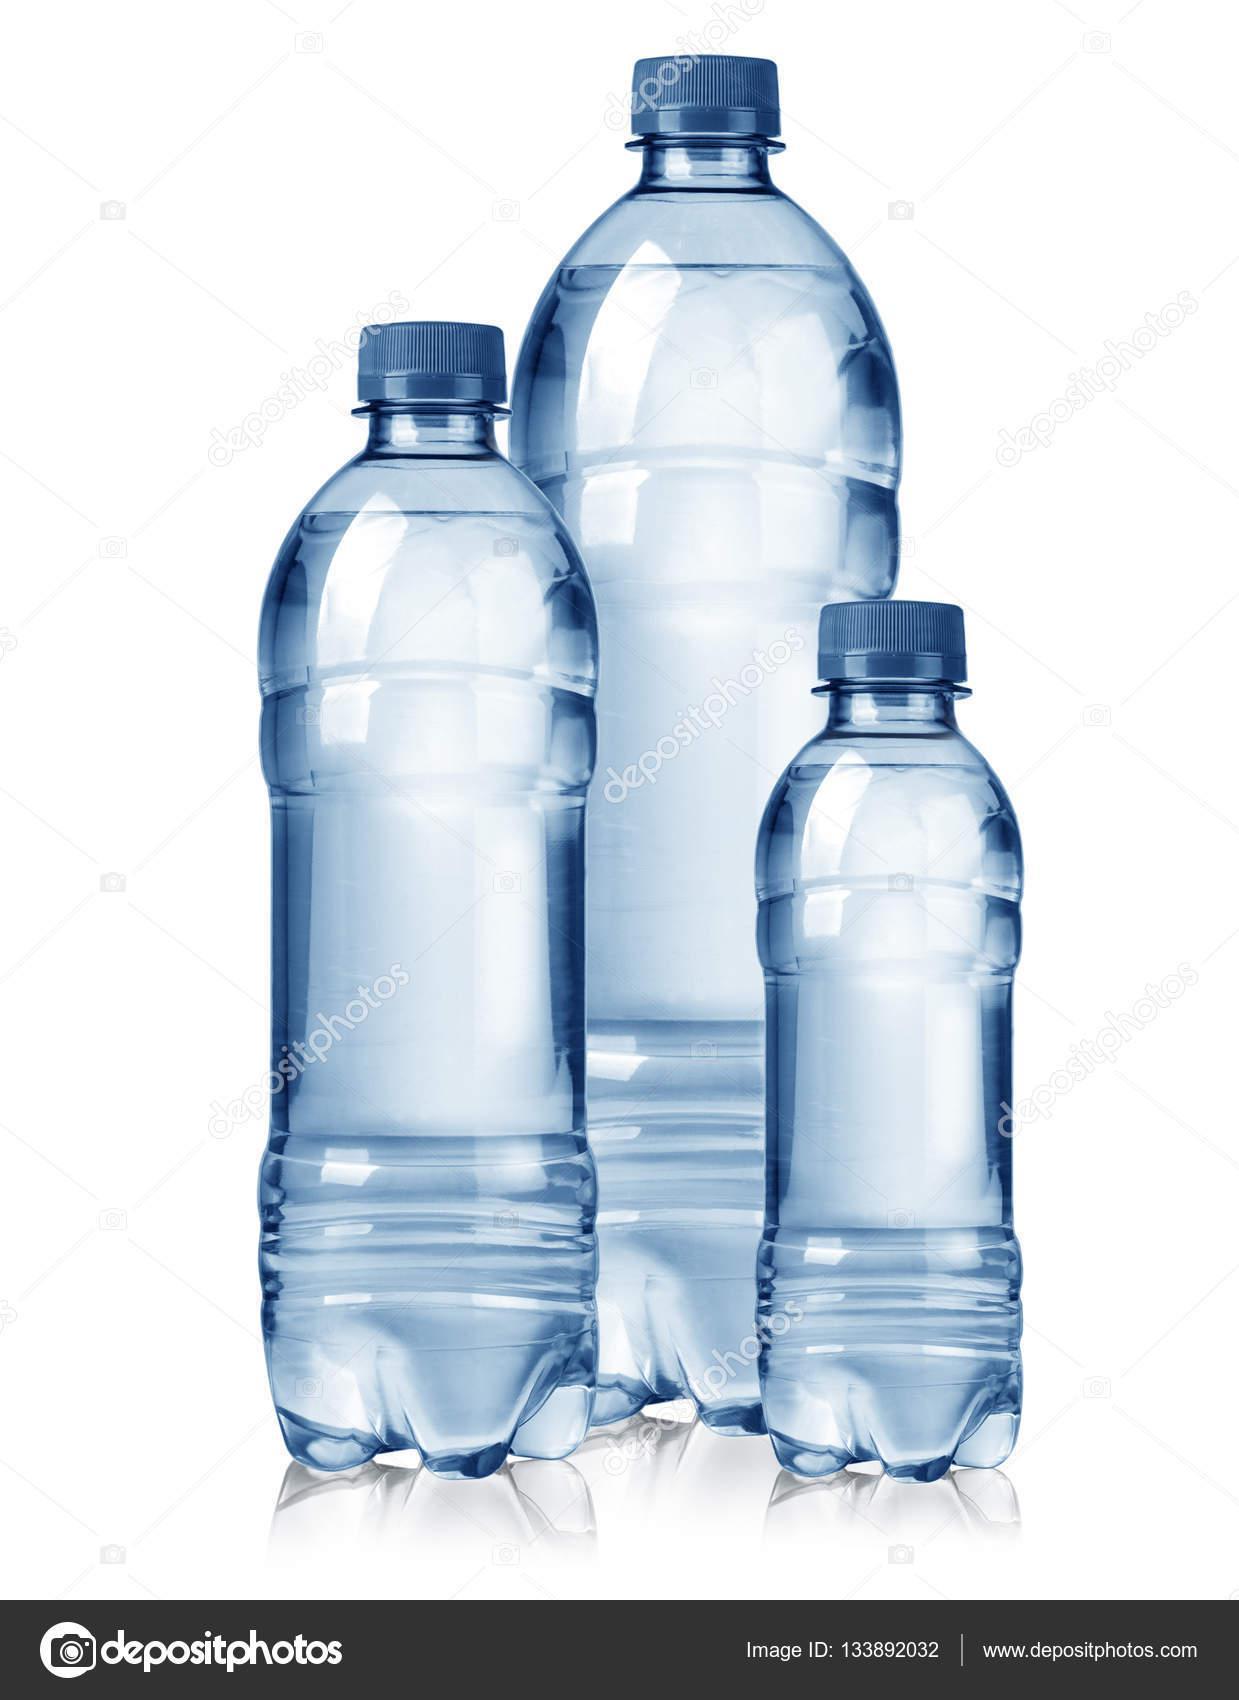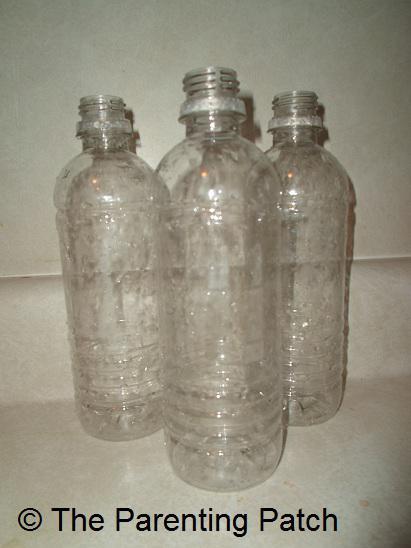The first image is the image on the left, the second image is the image on the right. Analyze the images presented: Is the assertion "The left image contains no more than one bottle." valid? Answer yes or no. No. The first image is the image on the left, the second image is the image on the right. Analyze the images presented: Is the assertion "Three water bottles with blue caps are in a row." valid? Answer yes or no. Yes. 